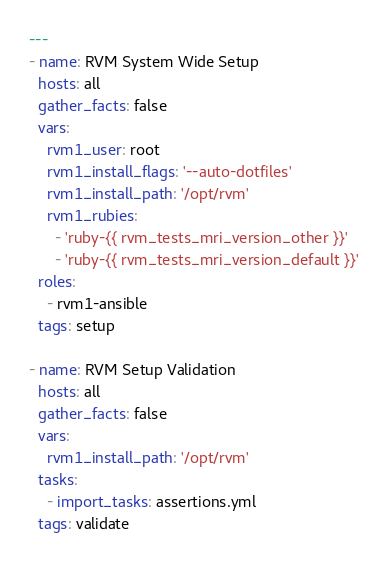Convert code to text. <code><loc_0><loc_0><loc_500><loc_500><_YAML_>---
- name: RVM System Wide Setup
  hosts: all
  gather_facts: false
  vars:
    rvm1_user: root
    rvm1_install_flags: '--auto-dotfiles'
    rvm1_install_path: '/opt/rvm'
    rvm1_rubies:
      - 'ruby-{{ rvm_tests_mri_version_other }}'
      - 'ruby-{{ rvm_tests_mri_version_default }}'
  roles:
    - rvm1-ansible
  tags: setup

- name: RVM Setup Validation
  hosts: all
  gather_facts: false
  vars:
    rvm1_install_path: '/opt/rvm'
  tasks:
    - import_tasks: assertions.yml
  tags: validate</code> 